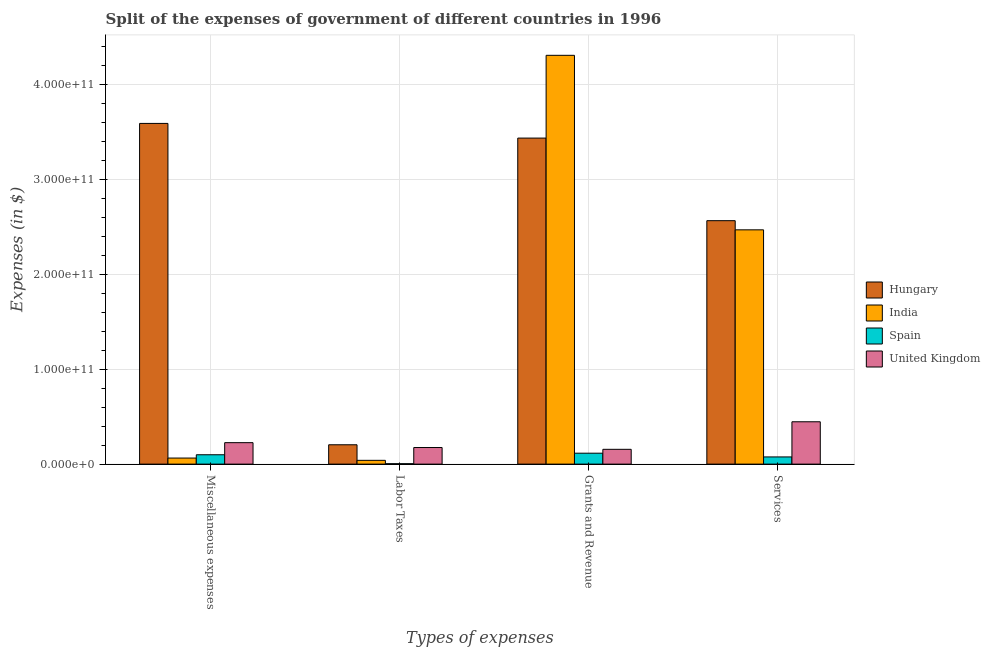How many different coloured bars are there?
Provide a short and direct response. 4. Are the number of bars on each tick of the X-axis equal?
Provide a succinct answer. Yes. How many bars are there on the 4th tick from the left?
Ensure brevity in your answer.  4. What is the label of the 4th group of bars from the left?
Provide a short and direct response. Services. What is the amount spent on grants and revenue in Hungary?
Ensure brevity in your answer.  3.44e+11. Across all countries, what is the maximum amount spent on grants and revenue?
Your answer should be very brief. 4.31e+11. Across all countries, what is the minimum amount spent on services?
Give a very brief answer. 7.57e+09. In which country was the amount spent on grants and revenue maximum?
Your answer should be compact. India. In which country was the amount spent on services minimum?
Give a very brief answer. Spain. What is the total amount spent on services in the graph?
Give a very brief answer. 5.56e+11. What is the difference between the amount spent on grants and revenue in United Kingdom and that in Spain?
Your response must be concise. 4.08e+09. What is the difference between the amount spent on grants and revenue in Hungary and the amount spent on miscellaneous expenses in Spain?
Ensure brevity in your answer.  3.34e+11. What is the average amount spent on labor taxes per country?
Keep it short and to the point. 1.06e+1. What is the difference between the amount spent on labor taxes and amount spent on services in United Kingdom?
Offer a very short reply. -2.71e+1. What is the ratio of the amount spent on miscellaneous expenses in Spain to that in Hungary?
Keep it short and to the point. 0.03. Is the difference between the amount spent on services in United Kingdom and Hungary greater than the difference between the amount spent on grants and revenue in United Kingdom and Hungary?
Offer a very short reply. Yes. What is the difference between the highest and the second highest amount spent on labor taxes?
Make the answer very short. 2.90e+09. What is the difference between the highest and the lowest amount spent on services?
Offer a terse response. 2.49e+11. Is the sum of the amount spent on grants and revenue in Spain and United Kingdom greater than the maximum amount spent on miscellaneous expenses across all countries?
Your answer should be very brief. No. What does the 2nd bar from the right in Grants and Revenue represents?
Provide a short and direct response. Spain. Is it the case that in every country, the sum of the amount spent on miscellaneous expenses and amount spent on labor taxes is greater than the amount spent on grants and revenue?
Make the answer very short. No. How many bars are there?
Give a very brief answer. 16. What is the difference between two consecutive major ticks on the Y-axis?
Offer a very short reply. 1.00e+11. Does the graph contain any zero values?
Your answer should be compact. No. Where does the legend appear in the graph?
Offer a very short reply. Center right. What is the title of the graph?
Make the answer very short. Split of the expenses of government of different countries in 1996. What is the label or title of the X-axis?
Ensure brevity in your answer.  Types of expenses. What is the label or title of the Y-axis?
Give a very brief answer. Expenses (in $). What is the Expenses (in $) of Hungary in Miscellaneous expenses?
Make the answer very short. 3.59e+11. What is the Expenses (in $) in India in Miscellaneous expenses?
Keep it short and to the point. 6.38e+09. What is the Expenses (in $) in Spain in Miscellaneous expenses?
Provide a succinct answer. 9.85e+09. What is the Expenses (in $) of United Kingdom in Miscellaneous expenses?
Give a very brief answer. 2.26e+1. What is the Expenses (in $) of Hungary in Labor Taxes?
Your answer should be compact. 2.04e+1. What is the Expenses (in $) in India in Labor Taxes?
Provide a succinct answer. 3.99e+09. What is the Expenses (in $) of Spain in Labor Taxes?
Your answer should be compact. 4.30e+08. What is the Expenses (in $) in United Kingdom in Labor Taxes?
Give a very brief answer. 1.75e+1. What is the Expenses (in $) of Hungary in Grants and Revenue?
Provide a short and direct response. 3.44e+11. What is the Expenses (in $) of India in Grants and Revenue?
Provide a short and direct response. 4.31e+11. What is the Expenses (in $) of Spain in Grants and Revenue?
Offer a terse response. 1.15e+1. What is the Expenses (in $) in United Kingdom in Grants and Revenue?
Ensure brevity in your answer.  1.56e+1. What is the Expenses (in $) of Hungary in Services?
Your answer should be compact. 2.57e+11. What is the Expenses (in $) of India in Services?
Offer a very short reply. 2.47e+11. What is the Expenses (in $) in Spain in Services?
Offer a terse response. 7.57e+09. What is the Expenses (in $) in United Kingdom in Services?
Your answer should be very brief. 4.46e+1. Across all Types of expenses, what is the maximum Expenses (in $) of Hungary?
Offer a terse response. 3.59e+11. Across all Types of expenses, what is the maximum Expenses (in $) of India?
Offer a very short reply. 4.31e+11. Across all Types of expenses, what is the maximum Expenses (in $) in Spain?
Offer a very short reply. 1.15e+1. Across all Types of expenses, what is the maximum Expenses (in $) in United Kingdom?
Offer a terse response. 4.46e+1. Across all Types of expenses, what is the minimum Expenses (in $) of Hungary?
Provide a succinct answer. 2.04e+1. Across all Types of expenses, what is the minimum Expenses (in $) of India?
Make the answer very short. 3.99e+09. Across all Types of expenses, what is the minimum Expenses (in $) of Spain?
Provide a short and direct response. 4.30e+08. Across all Types of expenses, what is the minimum Expenses (in $) in United Kingdom?
Provide a succinct answer. 1.56e+1. What is the total Expenses (in $) of Hungary in the graph?
Keep it short and to the point. 9.80e+11. What is the total Expenses (in $) in India in the graph?
Offer a terse response. 6.88e+11. What is the total Expenses (in $) in Spain in the graph?
Offer a very short reply. 2.94e+1. What is the total Expenses (in $) in United Kingdom in the graph?
Your response must be concise. 1.00e+11. What is the difference between the Expenses (in $) in Hungary in Miscellaneous expenses and that in Labor Taxes?
Offer a terse response. 3.39e+11. What is the difference between the Expenses (in $) of India in Miscellaneous expenses and that in Labor Taxes?
Your answer should be compact. 2.39e+09. What is the difference between the Expenses (in $) of Spain in Miscellaneous expenses and that in Labor Taxes?
Provide a short and direct response. 9.42e+09. What is the difference between the Expenses (in $) of United Kingdom in Miscellaneous expenses and that in Labor Taxes?
Make the answer very short. 5.13e+09. What is the difference between the Expenses (in $) in Hungary in Miscellaneous expenses and that in Grants and Revenue?
Offer a very short reply. 1.55e+1. What is the difference between the Expenses (in $) in India in Miscellaneous expenses and that in Grants and Revenue?
Offer a terse response. -4.24e+11. What is the difference between the Expenses (in $) of Spain in Miscellaneous expenses and that in Grants and Revenue?
Keep it short and to the point. -1.66e+09. What is the difference between the Expenses (in $) of United Kingdom in Miscellaneous expenses and that in Grants and Revenue?
Offer a very short reply. 7.02e+09. What is the difference between the Expenses (in $) in Hungary in Miscellaneous expenses and that in Services?
Offer a terse response. 1.03e+11. What is the difference between the Expenses (in $) of India in Miscellaneous expenses and that in Services?
Your answer should be very brief. -2.41e+11. What is the difference between the Expenses (in $) of Spain in Miscellaneous expenses and that in Services?
Offer a terse response. 2.29e+09. What is the difference between the Expenses (in $) of United Kingdom in Miscellaneous expenses and that in Services?
Keep it short and to the point. -2.20e+1. What is the difference between the Expenses (in $) of Hungary in Labor Taxes and that in Grants and Revenue?
Offer a terse response. -3.23e+11. What is the difference between the Expenses (in $) in India in Labor Taxes and that in Grants and Revenue?
Your answer should be compact. -4.27e+11. What is the difference between the Expenses (in $) of Spain in Labor Taxes and that in Grants and Revenue?
Keep it short and to the point. -1.11e+1. What is the difference between the Expenses (in $) in United Kingdom in Labor Taxes and that in Grants and Revenue?
Your response must be concise. 1.90e+09. What is the difference between the Expenses (in $) of Hungary in Labor Taxes and that in Services?
Keep it short and to the point. -2.36e+11. What is the difference between the Expenses (in $) of India in Labor Taxes and that in Services?
Provide a short and direct response. -2.43e+11. What is the difference between the Expenses (in $) of Spain in Labor Taxes and that in Services?
Keep it short and to the point. -7.14e+09. What is the difference between the Expenses (in $) in United Kingdom in Labor Taxes and that in Services?
Keep it short and to the point. -2.71e+1. What is the difference between the Expenses (in $) in Hungary in Grants and Revenue and that in Services?
Offer a terse response. 8.70e+1. What is the difference between the Expenses (in $) in India in Grants and Revenue and that in Services?
Offer a very short reply. 1.84e+11. What is the difference between the Expenses (in $) of Spain in Grants and Revenue and that in Services?
Provide a short and direct response. 3.94e+09. What is the difference between the Expenses (in $) of United Kingdom in Grants and Revenue and that in Services?
Your response must be concise. -2.90e+1. What is the difference between the Expenses (in $) of Hungary in Miscellaneous expenses and the Expenses (in $) of India in Labor Taxes?
Provide a short and direct response. 3.55e+11. What is the difference between the Expenses (in $) in Hungary in Miscellaneous expenses and the Expenses (in $) in Spain in Labor Taxes?
Ensure brevity in your answer.  3.59e+11. What is the difference between the Expenses (in $) in Hungary in Miscellaneous expenses and the Expenses (in $) in United Kingdom in Labor Taxes?
Offer a terse response. 3.42e+11. What is the difference between the Expenses (in $) of India in Miscellaneous expenses and the Expenses (in $) of Spain in Labor Taxes?
Your response must be concise. 5.95e+09. What is the difference between the Expenses (in $) of India in Miscellaneous expenses and the Expenses (in $) of United Kingdom in Labor Taxes?
Your answer should be very brief. -1.11e+1. What is the difference between the Expenses (in $) of Spain in Miscellaneous expenses and the Expenses (in $) of United Kingdom in Labor Taxes?
Provide a succinct answer. -7.63e+09. What is the difference between the Expenses (in $) of Hungary in Miscellaneous expenses and the Expenses (in $) of India in Grants and Revenue?
Your answer should be very brief. -7.18e+1. What is the difference between the Expenses (in $) in Hungary in Miscellaneous expenses and the Expenses (in $) in Spain in Grants and Revenue?
Your response must be concise. 3.48e+11. What is the difference between the Expenses (in $) in Hungary in Miscellaneous expenses and the Expenses (in $) in United Kingdom in Grants and Revenue?
Your response must be concise. 3.43e+11. What is the difference between the Expenses (in $) in India in Miscellaneous expenses and the Expenses (in $) in Spain in Grants and Revenue?
Your response must be concise. -5.13e+09. What is the difference between the Expenses (in $) in India in Miscellaneous expenses and the Expenses (in $) in United Kingdom in Grants and Revenue?
Provide a succinct answer. -9.20e+09. What is the difference between the Expenses (in $) in Spain in Miscellaneous expenses and the Expenses (in $) in United Kingdom in Grants and Revenue?
Your answer should be very brief. -5.73e+09. What is the difference between the Expenses (in $) of Hungary in Miscellaneous expenses and the Expenses (in $) of India in Services?
Keep it short and to the point. 1.12e+11. What is the difference between the Expenses (in $) of Hungary in Miscellaneous expenses and the Expenses (in $) of Spain in Services?
Provide a succinct answer. 3.51e+11. What is the difference between the Expenses (in $) of Hungary in Miscellaneous expenses and the Expenses (in $) of United Kingdom in Services?
Provide a short and direct response. 3.14e+11. What is the difference between the Expenses (in $) of India in Miscellaneous expenses and the Expenses (in $) of Spain in Services?
Your answer should be very brief. -1.19e+09. What is the difference between the Expenses (in $) in India in Miscellaneous expenses and the Expenses (in $) in United Kingdom in Services?
Your answer should be very brief. -3.82e+1. What is the difference between the Expenses (in $) in Spain in Miscellaneous expenses and the Expenses (in $) in United Kingdom in Services?
Provide a short and direct response. -3.48e+1. What is the difference between the Expenses (in $) in Hungary in Labor Taxes and the Expenses (in $) in India in Grants and Revenue?
Make the answer very short. -4.10e+11. What is the difference between the Expenses (in $) of Hungary in Labor Taxes and the Expenses (in $) of Spain in Grants and Revenue?
Your response must be concise. 8.87e+09. What is the difference between the Expenses (in $) in Hungary in Labor Taxes and the Expenses (in $) in United Kingdom in Grants and Revenue?
Offer a terse response. 4.80e+09. What is the difference between the Expenses (in $) of India in Labor Taxes and the Expenses (in $) of Spain in Grants and Revenue?
Keep it short and to the point. -7.52e+09. What is the difference between the Expenses (in $) in India in Labor Taxes and the Expenses (in $) in United Kingdom in Grants and Revenue?
Provide a short and direct response. -1.16e+1. What is the difference between the Expenses (in $) in Spain in Labor Taxes and the Expenses (in $) in United Kingdom in Grants and Revenue?
Offer a very short reply. -1.52e+1. What is the difference between the Expenses (in $) of Hungary in Labor Taxes and the Expenses (in $) of India in Services?
Ensure brevity in your answer.  -2.27e+11. What is the difference between the Expenses (in $) of Hungary in Labor Taxes and the Expenses (in $) of Spain in Services?
Your answer should be compact. 1.28e+1. What is the difference between the Expenses (in $) of Hungary in Labor Taxes and the Expenses (in $) of United Kingdom in Services?
Keep it short and to the point. -2.42e+1. What is the difference between the Expenses (in $) in India in Labor Taxes and the Expenses (in $) in Spain in Services?
Your response must be concise. -3.58e+09. What is the difference between the Expenses (in $) of India in Labor Taxes and the Expenses (in $) of United Kingdom in Services?
Offer a terse response. -4.06e+1. What is the difference between the Expenses (in $) in Spain in Labor Taxes and the Expenses (in $) in United Kingdom in Services?
Give a very brief answer. -4.42e+1. What is the difference between the Expenses (in $) in Hungary in Grants and Revenue and the Expenses (in $) in India in Services?
Your answer should be compact. 9.67e+1. What is the difference between the Expenses (in $) in Hungary in Grants and Revenue and the Expenses (in $) in Spain in Services?
Offer a very short reply. 3.36e+11. What is the difference between the Expenses (in $) in Hungary in Grants and Revenue and the Expenses (in $) in United Kingdom in Services?
Provide a short and direct response. 2.99e+11. What is the difference between the Expenses (in $) of India in Grants and Revenue and the Expenses (in $) of Spain in Services?
Offer a very short reply. 4.23e+11. What is the difference between the Expenses (in $) in India in Grants and Revenue and the Expenses (in $) in United Kingdom in Services?
Your answer should be very brief. 3.86e+11. What is the difference between the Expenses (in $) in Spain in Grants and Revenue and the Expenses (in $) in United Kingdom in Services?
Provide a short and direct response. -3.31e+1. What is the average Expenses (in $) in Hungary per Types of expenses?
Keep it short and to the point. 2.45e+11. What is the average Expenses (in $) of India per Types of expenses?
Offer a very short reply. 1.72e+11. What is the average Expenses (in $) in Spain per Types of expenses?
Offer a very short reply. 7.34e+09. What is the average Expenses (in $) of United Kingdom per Types of expenses?
Your response must be concise. 2.51e+1. What is the difference between the Expenses (in $) in Hungary and Expenses (in $) in India in Miscellaneous expenses?
Your answer should be compact. 3.53e+11. What is the difference between the Expenses (in $) in Hungary and Expenses (in $) in Spain in Miscellaneous expenses?
Your answer should be compact. 3.49e+11. What is the difference between the Expenses (in $) of Hungary and Expenses (in $) of United Kingdom in Miscellaneous expenses?
Ensure brevity in your answer.  3.36e+11. What is the difference between the Expenses (in $) in India and Expenses (in $) in Spain in Miscellaneous expenses?
Your answer should be compact. -3.47e+09. What is the difference between the Expenses (in $) of India and Expenses (in $) of United Kingdom in Miscellaneous expenses?
Offer a very short reply. -1.62e+1. What is the difference between the Expenses (in $) in Spain and Expenses (in $) in United Kingdom in Miscellaneous expenses?
Offer a very short reply. -1.28e+1. What is the difference between the Expenses (in $) in Hungary and Expenses (in $) in India in Labor Taxes?
Keep it short and to the point. 1.64e+1. What is the difference between the Expenses (in $) in Hungary and Expenses (in $) in Spain in Labor Taxes?
Your response must be concise. 2.00e+1. What is the difference between the Expenses (in $) of Hungary and Expenses (in $) of United Kingdom in Labor Taxes?
Make the answer very short. 2.90e+09. What is the difference between the Expenses (in $) of India and Expenses (in $) of Spain in Labor Taxes?
Your answer should be very brief. 3.56e+09. What is the difference between the Expenses (in $) in India and Expenses (in $) in United Kingdom in Labor Taxes?
Offer a terse response. -1.35e+1. What is the difference between the Expenses (in $) of Spain and Expenses (in $) of United Kingdom in Labor Taxes?
Offer a terse response. -1.71e+1. What is the difference between the Expenses (in $) in Hungary and Expenses (in $) in India in Grants and Revenue?
Offer a very short reply. -8.72e+1. What is the difference between the Expenses (in $) of Hungary and Expenses (in $) of Spain in Grants and Revenue?
Offer a very short reply. 3.32e+11. What is the difference between the Expenses (in $) in Hungary and Expenses (in $) in United Kingdom in Grants and Revenue?
Your answer should be compact. 3.28e+11. What is the difference between the Expenses (in $) of India and Expenses (in $) of Spain in Grants and Revenue?
Your answer should be very brief. 4.19e+11. What is the difference between the Expenses (in $) in India and Expenses (in $) in United Kingdom in Grants and Revenue?
Provide a short and direct response. 4.15e+11. What is the difference between the Expenses (in $) in Spain and Expenses (in $) in United Kingdom in Grants and Revenue?
Offer a very short reply. -4.08e+09. What is the difference between the Expenses (in $) in Hungary and Expenses (in $) in India in Services?
Offer a terse response. 9.64e+09. What is the difference between the Expenses (in $) of Hungary and Expenses (in $) of Spain in Services?
Your answer should be compact. 2.49e+11. What is the difference between the Expenses (in $) in Hungary and Expenses (in $) in United Kingdom in Services?
Make the answer very short. 2.12e+11. What is the difference between the Expenses (in $) of India and Expenses (in $) of Spain in Services?
Your answer should be compact. 2.39e+11. What is the difference between the Expenses (in $) of India and Expenses (in $) of United Kingdom in Services?
Your answer should be compact. 2.02e+11. What is the difference between the Expenses (in $) of Spain and Expenses (in $) of United Kingdom in Services?
Provide a short and direct response. -3.71e+1. What is the ratio of the Expenses (in $) of Hungary in Miscellaneous expenses to that in Labor Taxes?
Offer a very short reply. 17.61. What is the ratio of the Expenses (in $) in India in Miscellaneous expenses to that in Labor Taxes?
Ensure brevity in your answer.  1.6. What is the ratio of the Expenses (in $) in Spain in Miscellaneous expenses to that in Labor Taxes?
Your answer should be compact. 22.92. What is the ratio of the Expenses (in $) of United Kingdom in Miscellaneous expenses to that in Labor Taxes?
Make the answer very short. 1.29. What is the ratio of the Expenses (in $) in Hungary in Miscellaneous expenses to that in Grants and Revenue?
Your response must be concise. 1.04. What is the ratio of the Expenses (in $) in India in Miscellaneous expenses to that in Grants and Revenue?
Provide a succinct answer. 0.01. What is the ratio of the Expenses (in $) in Spain in Miscellaneous expenses to that in Grants and Revenue?
Ensure brevity in your answer.  0.86. What is the ratio of the Expenses (in $) of United Kingdom in Miscellaneous expenses to that in Grants and Revenue?
Ensure brevity in your answer.  1.45. What is the ratio of the Expenses (in $) of Hungary in Miscellaneous expenses to that in Services?
Offer a terse response. 1.4. What is the ratio of the Expenses (in $) of India in Miscellaneous expenses to that in Services?
Your answer should be compact. 0.03. What is the ratio of the Expenses (in $) of Spain in Miscellaneous expenses to that in Services?
Offer a very short reply. 1.3. What is the ratio of the Expenses (in $) of United Kingdom in Miscellaneous expenses to that in Services?
Provide a succinct answer. 0.51. What is the ratio of the Expenses (in $) of Hungary in Labor Taxes to that in Grants and Revenue?
Offer a very short reply. 0.06. What is the ratio of the Expenses (in $) in India in Labor Taxes to that in Grants and Revenue?
Keep it short and to the point. 0.01. What is the ratio of the Expenses (in $) of Spain in Labor Taxes to that in Grants and Revenue?
Offer a very short reply. 0.04. What is the ratio of the Expenses (in $) in United Kingdom in Labor Taxes to that in Grants and Revenue?
Give a very brief answer. 1.12. What is the ratio of the Expenses (in $) in Hungary in Labor Taxes to that in Services?
Provide a short and direct response. 0.08. What is the ratio of the Expenses (in $) of India in Labor Taxes to that in Services?
Offer a very short reply. 0.02. What is the ratio of the Expenses (in $) in Spain in Labor Taxes to that in Services?
Make the answer very short. 0.06. What is the ratio of the Expenses (in $) of United Kingdom in Labor Taxes to that in Services?
Offer a very short reply. 0.39. What is the ratio of the Expenses (in $) of Hungary in Grants and Revenue to that in Services?
Offer a terse response. 1.34. What is the ratio of the Expenses (in $) in India in Grants and Revenue to that in Services?
Give a very brief answer. 1.74. What is the ratio of the Expenses (in $) in Spain in Grants and Revenue to that in Services?
Offer a very short reply. 1.52. What is the ratio of the Expenses (in $) of United Kingdom in Grants and Revenue to that in Services?
Give a very brief answer. 0.35. What is the difference between the highest and the second highest Expenses (in $) of Hungary?
Give a very brief answer. 1.55e+1. What is the difference between the highest and the second highest Expenses (in $) of India?
Provide a succinct answer. 1.84e+11. What is the difference between the highest and the second highest Expenses (in $) in Spain?
Make the answer very short. 1.66e+09. What is the difference between the highest and the second highest Expenses (in $) in United Kingdom?
Provide a succinct answer. 2.20e+1. What is the difference between the highest and the lowest Expenses (in $) in Hungary?
Your answer should be very brief. 3.39e+11. What is the difference between the highest and the lowest Expenses (in $) in India?
Provide a short and direct response. 4.27e+11. What is the difference between the highest and the lowest Expenses (in $) of Spain?
Provide a succinct answer. 1.11e+1. What is the difference between the highest and the lowest Expenses (in $) of United Kingdom?
Make the answer very short. 2.90e+1. 